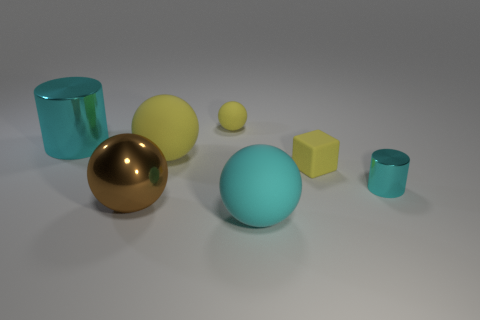Subtract all big cyan rubber spheres. How many spheres are left? 3 Add 2 cyan matte balls. How many objects exist? 9 Subtract all cylinders. How many objects are left? 5 Subtract 2 cylinders. How many cylinders are left? 0 Subtract all gray balls. Subtract all cyan cubes. How many balls are left? 4 Subtract all gray blocks. How many purple cylinders are left? 0 Subtract all balls. Subtract all big yellow spheres. How many objects are left? 2 Add 6 brown balls. How many brown balls are left? 7 Add 1 big gray cubes. How many big gray cubes exist? 1 Subtract all yellow balls. How many balls are left? 2 